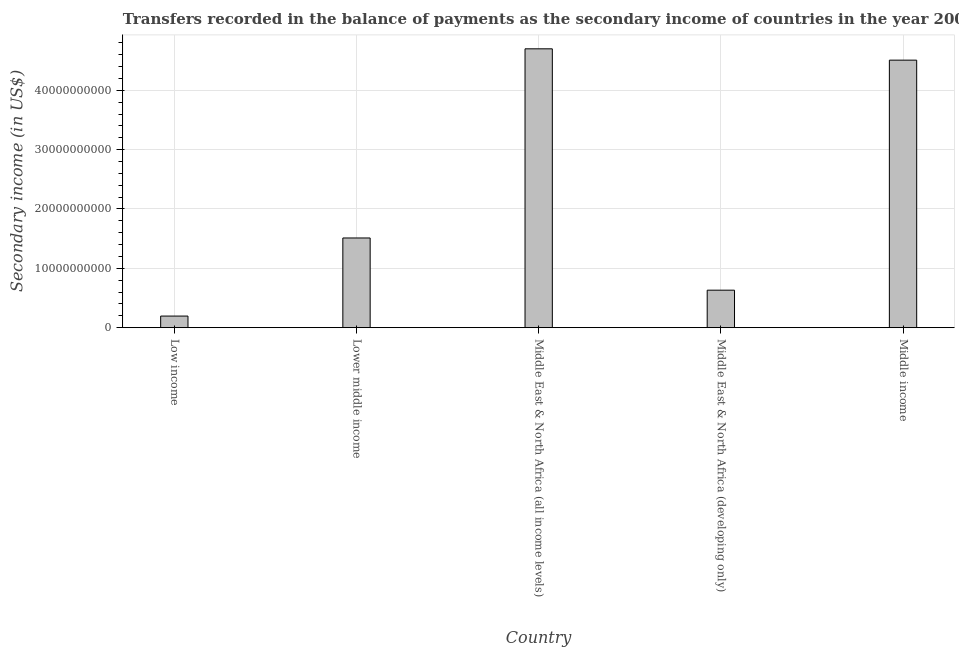Does the graph contain grids?
Your answer should be very brief. Yes. What is the title of the graph?
Offer a terse response. Transfers recorded in the balance of payments as the secondary income of countries in the year 2008. What is the label or title of the X-axis?
Make the answer very short. Country. What is the label or title of the Y-axis?
Your response must be concise. Secondary income (in US$). What is the amount of secondary income in Middle income?
Make the answer very short. 4.51e+1. Across all countries, what is the maximum amount of secondary income?
Your response must be concise. 4.70e+1. Across all countries, what is the minimum amount of secondary income?
Ensure brevity in your answer.  1.95e+09. In which country was the amount of secondary income maximum?
Ensure brevity in your answer.  Middle East & North Africa (all income levels). In which country was the amount of secondary income minimum?
Provide a succinct answer. Low income. What is the sum of the amount of secondary income?
Ensure brevity in your answer.  1.15e+11. What is the difference between the amount of secondary income in Low income and Middle income?
Give a very brief answer. -4.31e+1. What is the average amount of secondary income per country?
Offer a terse response. 2.31e+1. What is the median amount of secondary income?
Your response must be concise. 1.51e+1. What is the ratio of the amount of secondary income in Middle East & North Africa (all income levels) to that in Middle East & North Africa (developing only)?
Keep it short and to the point. 7.44. What is the difference between the highest and the second highest amount of secondary income?
Ensure brevity in your answer.  1.91e+09. What is the difference between the highest and the lowest amount of secondary income?
Give a very brief answer. 4.50e+1. In how many countries, is the amount of secondary income greater than the average amount of secondary income taken over all countries?
Your response must be concise. 2. How many bars are there?
Keep it short and to the point. 5. Are all the bars in the graph horizontal?
Provide a succinct answer. No. What is the Secondary income (in US$) in Low income?
Give a very brief answer. 1.95e+09. What is the Secondary income (in US$) in Lower middle income?
Your answer should be compact. 1.51e+1. What is the Secondary income (in US$) of Middle East & North Africa (all income levels)?
Your response must be concise. 4.70e+1. What is the Secondary income (in US$) in Middle East & North Africa (developing only)?
Your answer should be compact. 6.32e+09. What is the Secondary income (in US$) of Middle income?
Give a very brief answer. 4.51e+1. What is the difference between the Secondary income (in US$) in Low income and Lower middle income?
Your answer should be compact. -1.32e+1. What is the difference between the Secondary income (in US$) in Low income and Middle East & North Africa (all income levels)?
Your response must be concise. -4.50e+1. What is the difference between the Secondary income (in US$) in Low income and Middle East & North Africa (developing only)?
Keep it short and to the point. -4.36e+09. What is the difference between the Secondary income (in US$) in Low income and Middle income?
Make the answer very short. -4.31e+1. What is the difference between the Secondary income (in US$) in Lower middle income and Middle East & North Africa (all income levels)?
Provide a succinct answer. -3.19e+1. What is the difference between the Secondary income (in US$) in Lower middle income and Middle East & North Africa (developing only)?
Your answer should be compact. 8.80e+09. What is the difference between the Secondary income (in US$) in Lower middle income and Middle income?
Make the answer very short. -3.00e+1. What is the difference between the Secondary income (in US$) in Middle East & North Africa (all income levels) and Middle East & North Africa (developing only)?
Provide a succinct answer. 4.07e+1. What is the difference between the Secondary income (in US$) in Middle East & North Africa (all income levels) and Middle income?
Your answer should be compact. 1.91e+09. What is the difference between the Secondary income (in US$) in Middle East & North Africa (developing only) and Middle income?
Your response must be concise. -3.88e+1. What is the ratio of the Secondary income (in US$) in Low income to that in Lower middle income?
Offer a terse response. 0.13. What is the ratio of the Secondary income (in US$) in Low income to that in Middle East & North Africa (all income levels)?
Your response must be concise. 0.04. What is the ratio of the Secondary income (in US$) in Low income to that in Middle East & North Africa (developing only)?
Your answer should be very brief. 0.31. What is the ratio of the Secondary income (in US$) in Low income to that in Middle income?
Provide a succinct answer. 0.04. What is the ratio of the Secondary income (in US$) in Lower middle income to that in Middle East & North Africa (all income levels)?
Offer a terse response. 0.32. What is the ratio of the Secondary income (in US$) in Lower middle income to that in Middle East & North Africa (developing only)?
Offer a terse response. 2.39. What is the ratio of the Secondary income (in US$) in Lower middle income to that in Middle income?
Your answer should be very brief. 0.34. What is the ratio of the Secondary income (in US$) in Middle East & North Africa (all income levels) to that in Middle East & North Africa (developing only)?
Keep it short and to the point. 7.44. What is the ratio of the Secondary income (in US$) in Middle East & North Africa (all income levels) to that in Middle income?
Keep it short and to the point. 1.04. What is the ratio of the Secondary income (in US$) in Middle East & North Africa (developing only) to that in Middle income?
Ensure brevity in your answer.  0.14. 